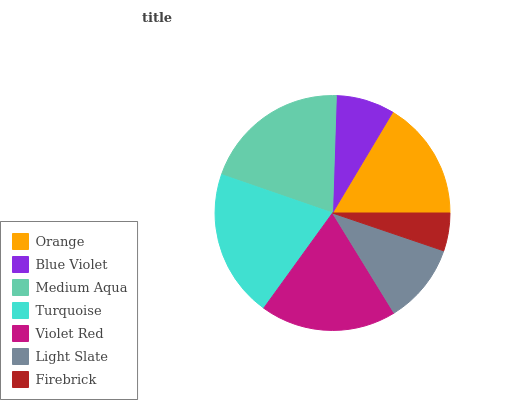Is Firebrick the minimum?
Answer yes or no. Yes. Is Turquoise the maximum?
Answer yes or no. Yes. Is Blue Violet the minimum?
Answer yes or no. No. Is Blue Violet the maximum?
Answer yes or no. No. Is Orange greater than Blue Violet?
Answer yes or no. Yes. Is Blue Violet less than Orange?
Answer yes or no. Yes. Is Blue Violet greater than Orange?
Answer yes or no. No. Is Orange less than Blue Violet?
Answer yes or no. No. Is Orange the high median?
Answer yes or no. Yes. Is Orange the low median?
Answer yes or no. Yes. Is Blue Violet the high median?
Answer yes or no. No. Is Turquoise the low median?
Answer yes or no. No. 